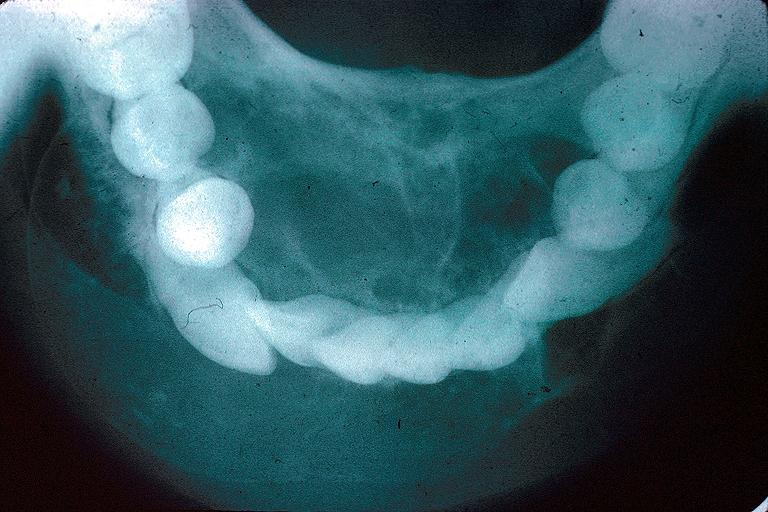what is present?
Answer the question using a single word or phrase. Oral 